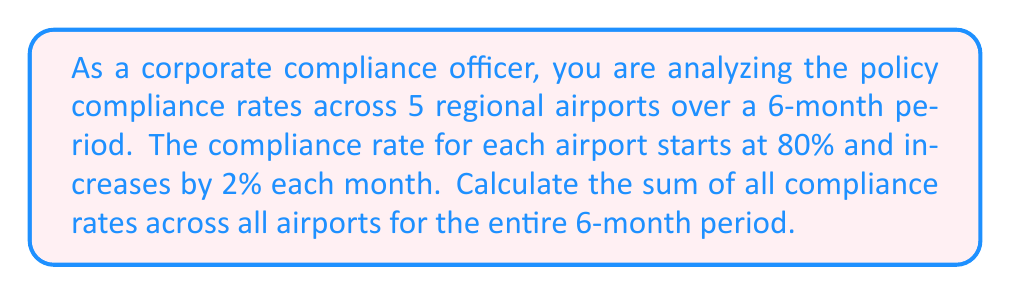Give your solution to this math problem. To solve this problem, we need to use the concept of arithmetic sequences and series.

1) First, let's identify the sequence for a single airport:
   80%, 82%, 84%, 86%, 88%, 90%

   This is an arithmetic sequence with:
   $a_1 = 80$ (first term)
   $d = 2$ (common difference)
   $n = 6$ (number of terms)

2) The sum of an arithmetic sequence is given by the formula:
   $S_n = \frac{n}{2}(a_1 + a_n)$
   where $a_n = a_1 + (n-1)d$

3) For a single airport:
   $a_6 = 80 + (6-1)2 = 90$
   $S_6 = \frac{6}{2}(80 + 90) = 3(170) = 510$

4) Since there are 5 airports, and each follows the same sequence, we multiply this sum by 5:

   Total sum = $5 * 510 = 2550$

5) However, this sum is in percentage points. To convert to a decimal, we divide by 100:

   $\frac{2550}{100} = 25.50$

Therefore, the sum of all compliance rates across all airports for the entire 6-month period is 25.50.
Answer: 25.50 